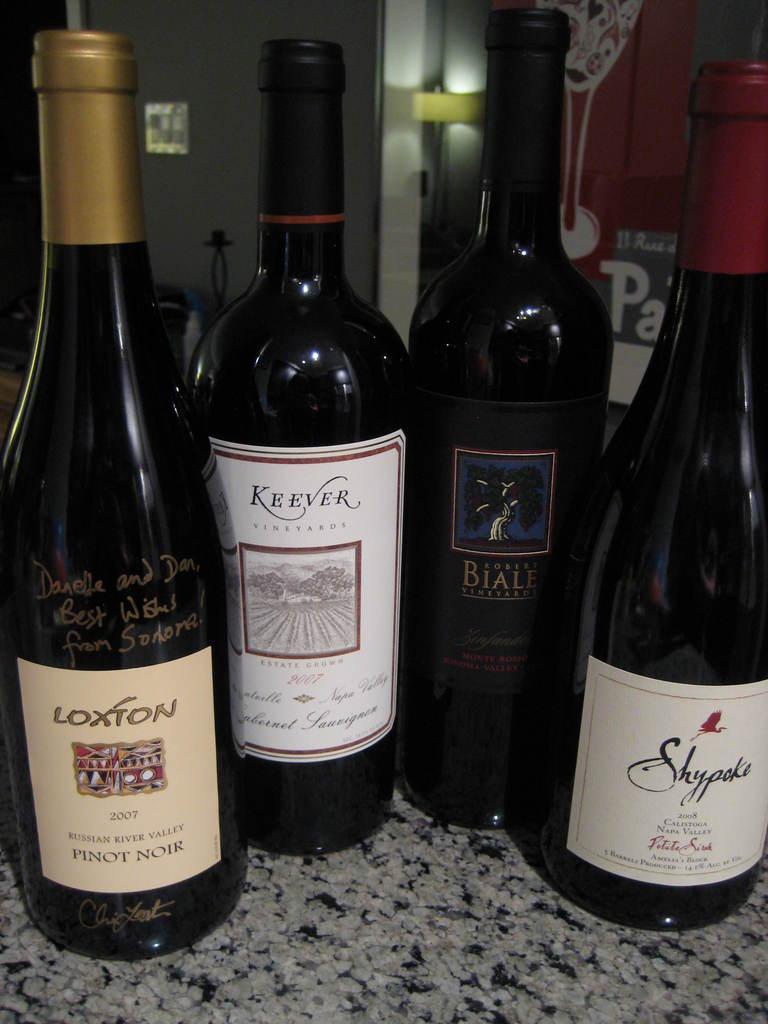What year is the pinot nior on the left?
Offer a terse response. 2007. What name is on the left hand bottle?
Offer a very short reply. Loxton. 